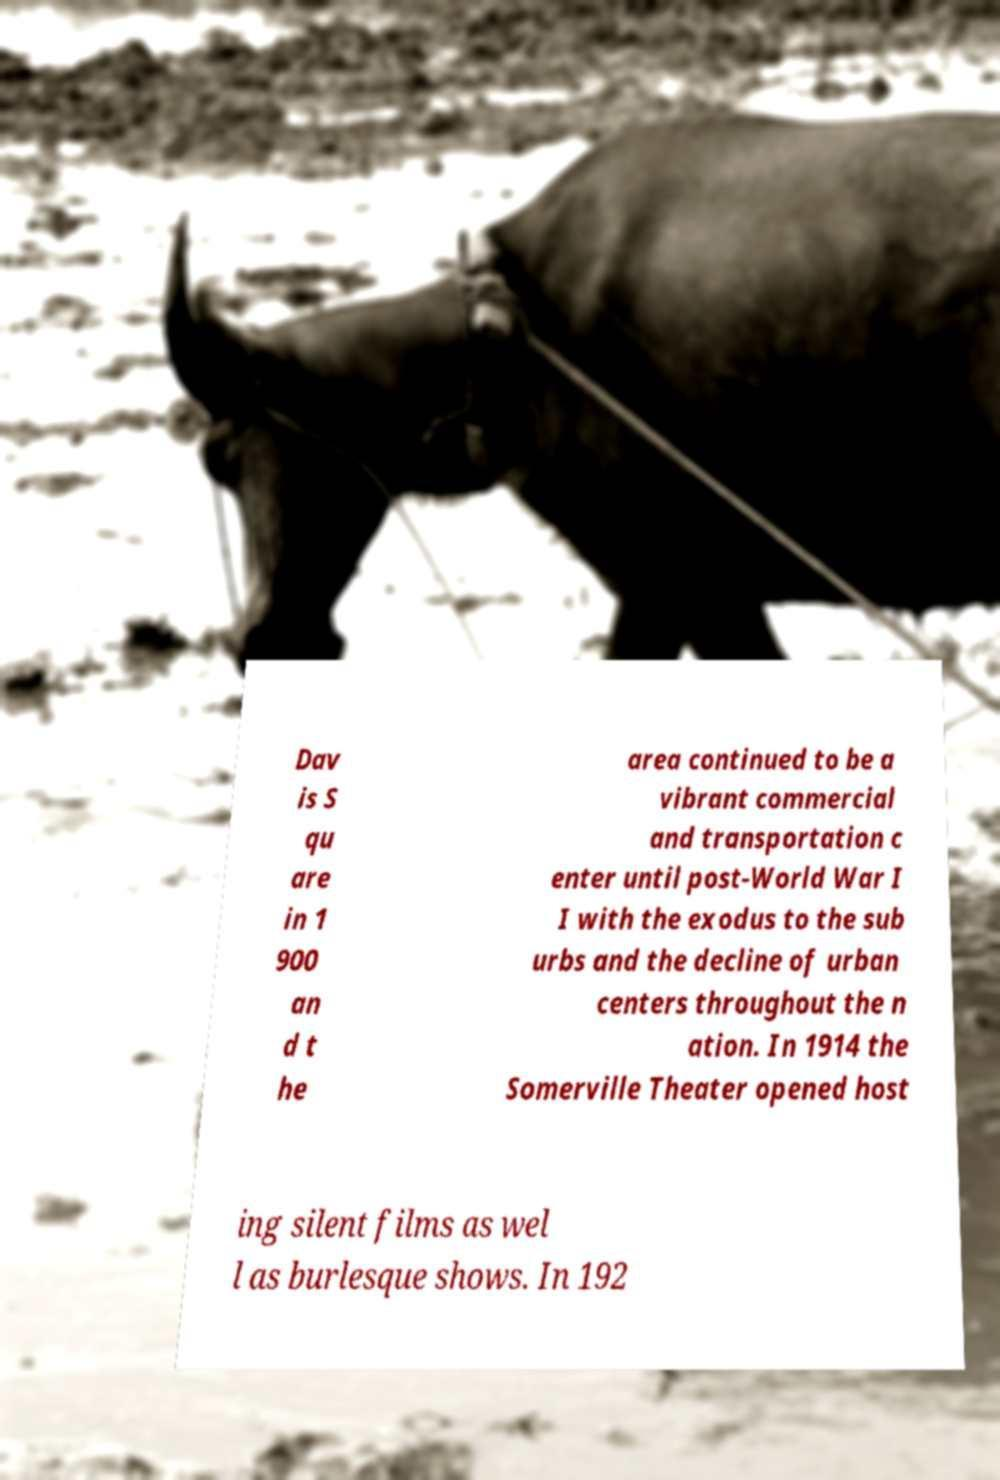Can you read and provide the text displayed in the image?This photo seems to have some interesting text. Can you extract and type it out for me? Dav is S qu are in 1 900 an d t he area continued to be a vibrant commercial and transportation c enter until post-World War I I with the exodus to the sub urbs and the decline of urban centers throughout the n ation. In 1914 the Somerville Theater opened host ing silent films as wel l as burlesque shows. In 192 